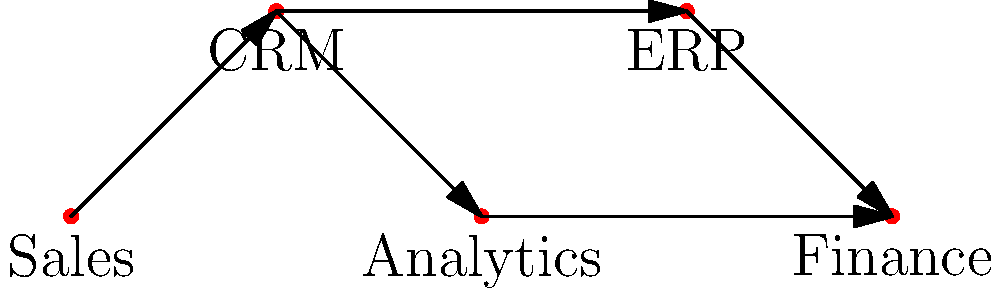In the given network diagram representing data flow in an organization, which department acts as the central hub for data distribution? To determine the central hub for data distribution, we need to analyze the data flow represented by the arrows in the diagram. Let's follow these steps:

1. Identify all departments: Sales, CRM, Analytics, ERP, and Finance.
2. Observe the direction of arrows (data flow):
   - Sales sends data to CRM
   - CRM sends data to Analytics and ERP
   - Analytics sends data to Finance
   - ERP sends data to Finance
3. Count incoming and outgoing connections for each department:
   - Sales: 0 in, 1 out
   - CRM: 1 in, 2 out
   - Analytics: 1 in, 1 out
   - ERP: 1 in, 1 out
   - Finance: 2 in, 0 out
4. Identify the department with the most outgoing connections and a significant number of incoming connections.

CRM has the most outgoing connections (2) and also has an incoming connection, making it the central hub for data distribution in this network.
Answer: CRM 